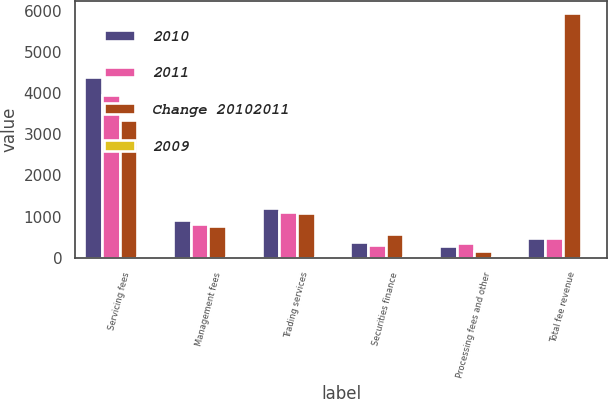<chart> <loc_0><loc_0><loc_500><loc_500><stacked_bar_chart><ecel><fcel>Servicing fees<fcel>Management fees<fcel>Trading services<fcel>Securities finance<fcel>Processing fees and other<fcel>Total fee revenue<nl><fcel>2010<fcel>4382<fcel>917<fcel>1220<fcel>378<fcel>297<fcel>474<nl><fcel>2011<fcel>3938<fcel>829<fcel>1106<fcel>318<fcel>349<fcel>474<nl><fcel>Change 20102011<fcel>3334<fcel>766<fcel>1094<fcel>570<fcel>171<fcel>5935<nl><fcel>2009<fcel>11<fcel>11<fcel>10<fcel>19<fcel>15<fcel>10<nl></chart> 